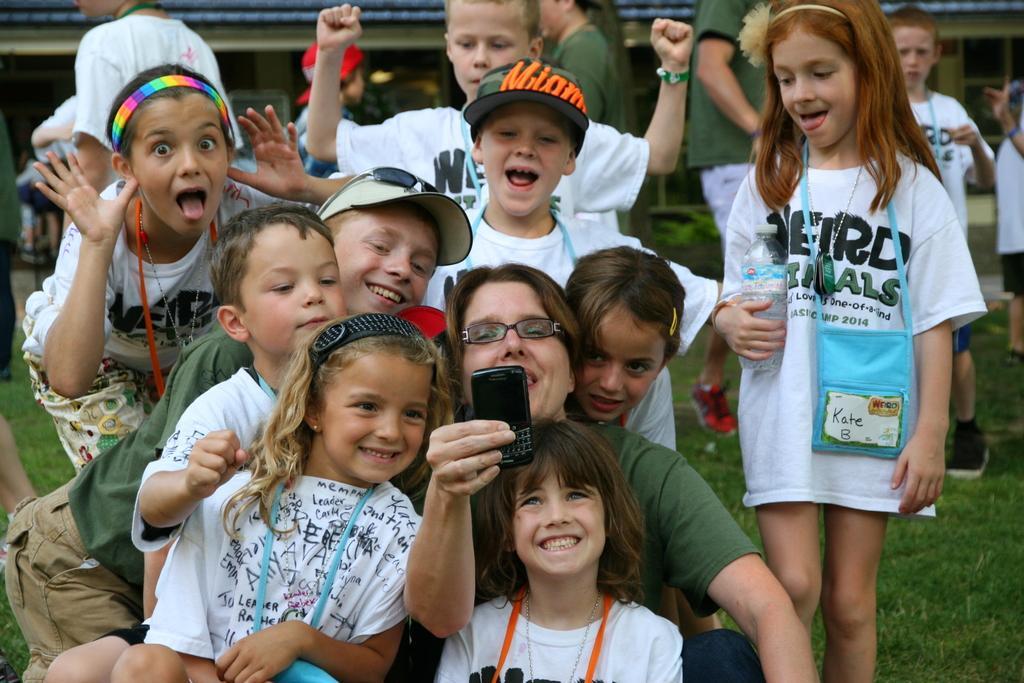How would you summarize this image in a sentence or two? In this image we can see few people on the ground, a person is holding a cellphone and there is a building in the background. 